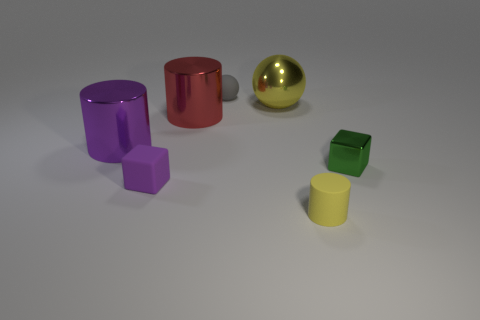Add 1 tiny yellow metal cylinders. How many objects exist? 8 Subtract all large cylinders. How many cylinders are left? 1 Subtract 2 balls. How many balls are left? 0 Subtract all yellow balls. How many balls are left? 1 Subtract all blocks. How many objects are left? 5 Subtract all cyan balls. How many yellow cylinders are left? 1 Subtract all cylinders. Subtract all big shiny objects. How many objects are left? 1 Add 6 small green objects. How many small green objects are left? 7 Add 2 big purple shiny objects. How many big purple shiny objects exist? 3 Subtract 1 yellow balls. How many objects are left? 6 